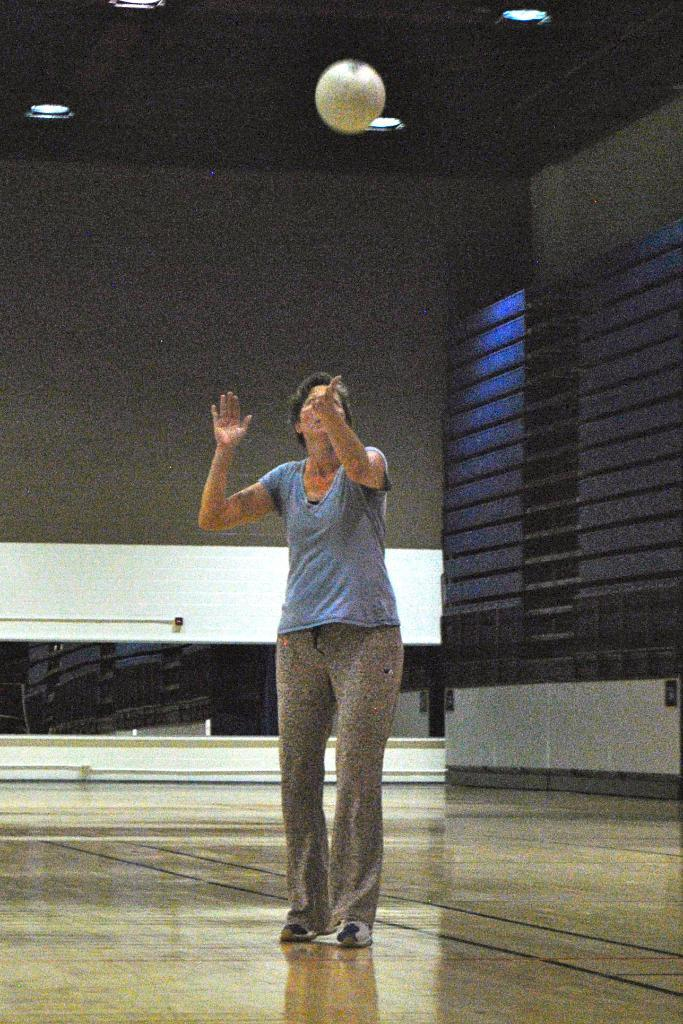What is the main subject of the image? There is a person standing in the image. Where is the person standing? The person is standing on the floor. What is happening with the ball in the image? The ball is in the air in the image. What can be seen in the background of the image? There is a wall in the background of the image. What is visible at the top of the image? There are lights visible at the top of the image. What type of suit is the person wearing in the image? There is no suit visible in the image; the person is not wearing any clothing mentioned in the facts. Is there a volcano erupting in the background of the image? No, there is no volcano present in the image; only a wall is visible in the background. 